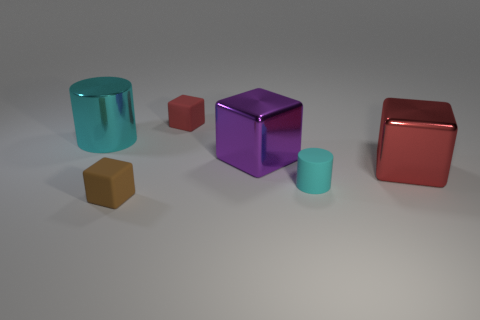What number of small matte cubes are there?
Keep it short and to the point. 2. Does the large purple cube have the same material as the big cyan object?
Your answer should be very brief. Yes. The cyan thing in front of the cylinder that is on the left side of the large metallic block to the left of the large red block is what shape?
Your answer should be compact. Cylinder. Is the material of the tiny cylinder in front of the big purple object the same as the tiny block to the right of the brown rubber block?
Keep it short and to the point. Yes. What is the material of the tiny red thing?
Keep it short and to the point. Rubber. How many other big purple things are the same shape as the purple metallic object?
Keep it short and to the point. 0. There is a tiny object that is the same color as the big shiny cylinder; what is its material?
Offer a terse response. Rubber. Is there anything else that has the same shape as the big purple shiny thing?
Offer a very short reply. Yes. What color is the tiny rubber block behind the large metal object on the left side of the large metallic cube that is on the left side of the large red block?
Give a very brief answer. Red. How many big objects are brown blocks or gray rubber things?
Make the answer very short. 0. 